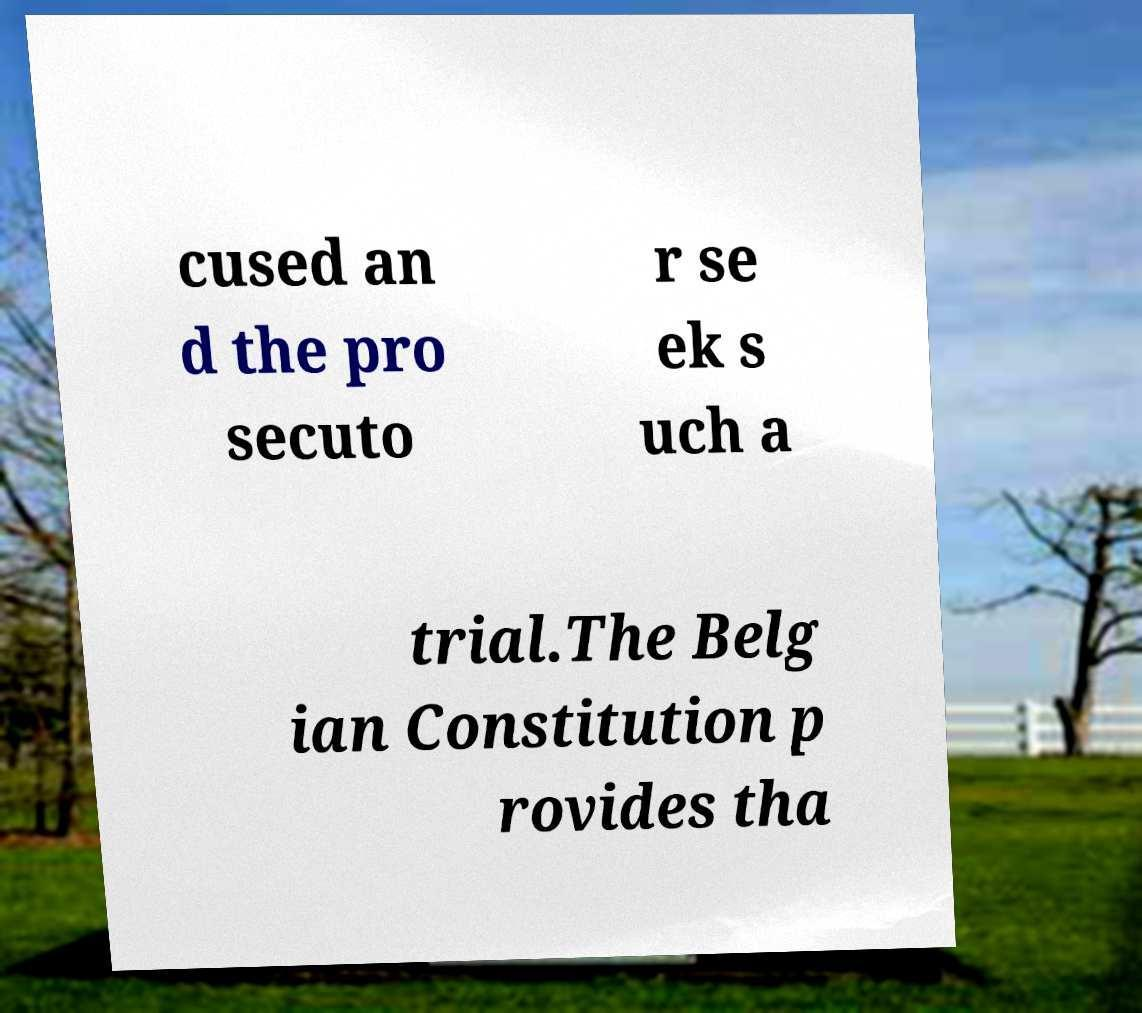I need the written content from this picture converted into text. Can you do that? cused an d the pro secuto r se ek s uch a trial.The Belg ian Constitution p rovides tha 